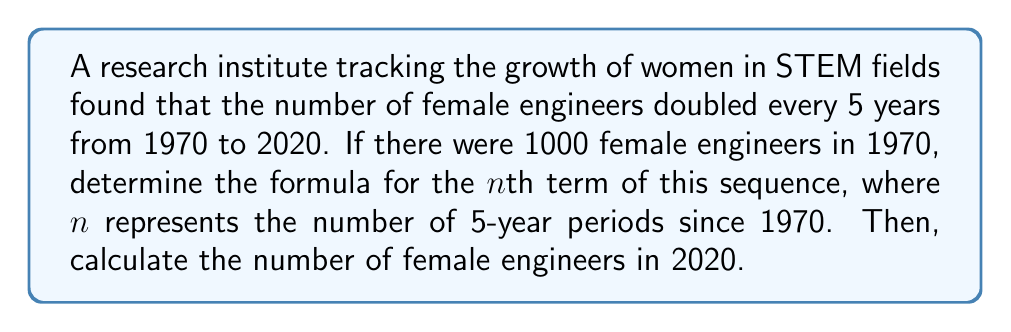Teach me how to tackle this problem. Let's approach this step-by-step:

1) First, let's identify the sequence:
   1970 (n=0): 1000
   1975 (n=1): 2000
   1980 (n=2): 4000
   ...and so on

2) We can see that this is a geometric sequence with a common ratio of 2.

3) The general formula for a geometric sequence is:
   $$a_n = a_1 \cdot r^{n-1}$$
   where $a_n$ is the nth term, $a_1$ is the first term, and r is the common ratio.

4) In our case:
   $a_1 = 1000$ (the number in 1970)
   $r = 2$ (doubles every period)
   n starts at 0 for 1970

5) We need to modify the formula slightly to account for n starting at 0:
   $$a_n = 1000 \cdot 2^n$$

6) To find the number in 2020:
   - 2020 is 50 years after 1970
   - 50 years = 10 five-year periods
   - So n = 10

7) Plugging in n = 10:
   $$a_{10} = 1000 \cdot 2^{10} = 1000 \cdot 1024 = 1,024,000$$

Therefore, in 2020, there would be 1,024,000 female engineers according to this model.
Answer: $a_n = 1000 \cdot 2^n$; 1,024,000 female engineers in 2020 